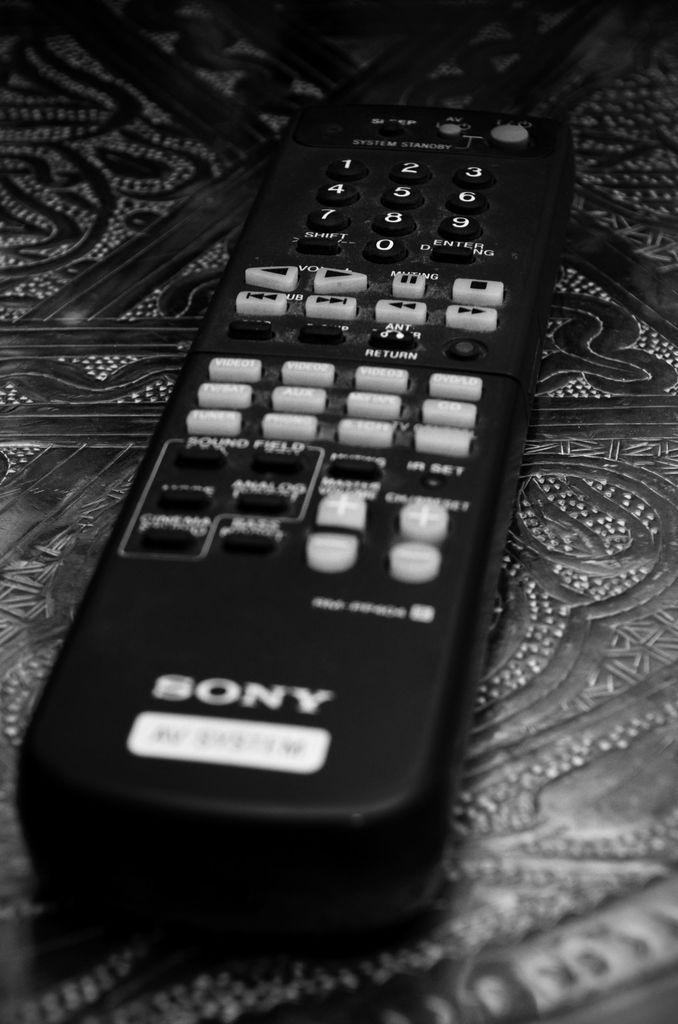What brand of tv does this remote control control?
Ensure brevity in your answer.  Sony. Does this remote have an "enter" button?
Provide a succinct answer. Yes. 